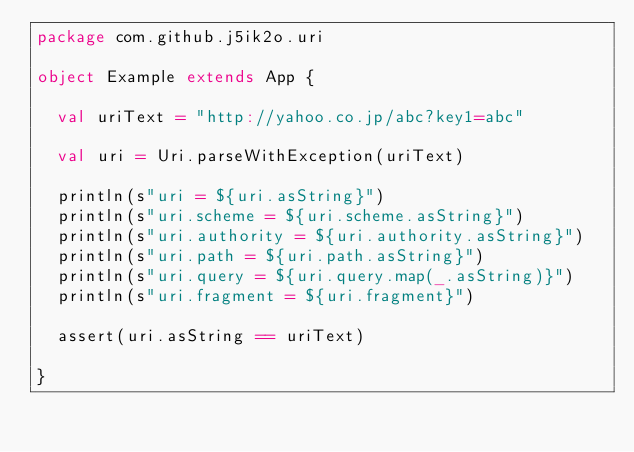<code> <loc_0><loc_0><loc_500><loc_500><_Scala_>package com.github.j5ik2o.uri

object Example extends App {

  val uriText = "http://yahoo.co.jp/abc?key1=abc"

  val uri = Uri.parseWithException(uriText)

  println(s"uri = ${uri.asString}")
  println(s"uri.scheme = ${uri.scheme.asString}")
  println(s"uri.authority = ${uri.authority.asString}")
  println(s"uri.path = ${uri.path.asString}")
  println(s"uri.query = ${uri.query.map(_.asString)}")
  println(s"uri.fragment = ${uri.fragment}")

  assert(uri.asString == uriText)

}
</code> 